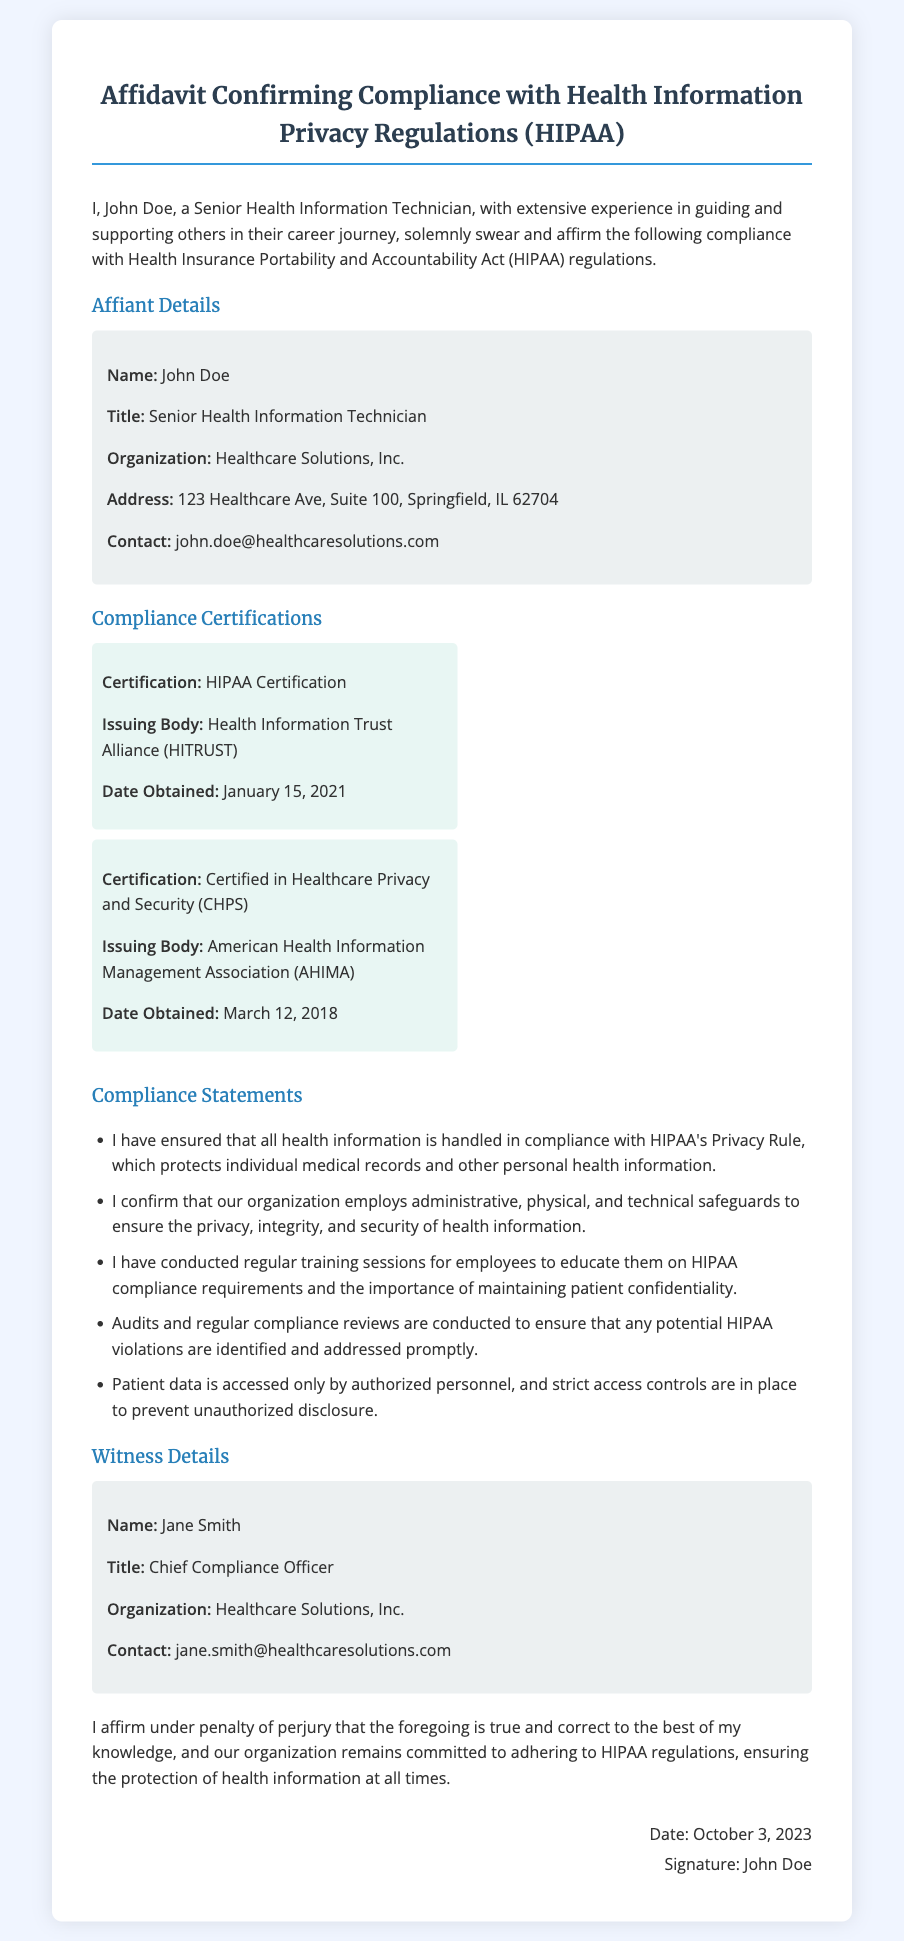What is the name of the affiant? The affiant's name is stated in the header of the affidavit.
Answer: John Doe What is the title of the affiant? The title is mentioned in the affiant details section of the document.
Answer: Senior Health Information Technician What organization does the affiant work for? The organization is listed in the affiant details section.
Answer: Healthcare Solutions, Inc When was the HIPAA Certification obtained? The date is found under the Compliance Certifications section of the document.
Answer: January 15, 2021 Who is the witness of the affidavit? The witness's name is provided in the witness details section.
Answer: Jane Smith What is the contact email of the affiant? The email is included in the affiant details.
Answer: john.doe@healthcaresolutions.com What type of safeguards does the organization employ? This information can be found in the compliance statements section of the document.
Answer: Administrative, physical, and technical safeguards How many compliance certifications are listed? The number of certifications can be counted in the Compliance Certifications section.
Answer: Two What is the date signed on the affidavit? The signature section shows the date clearly.
Answer: October 3, 2023 